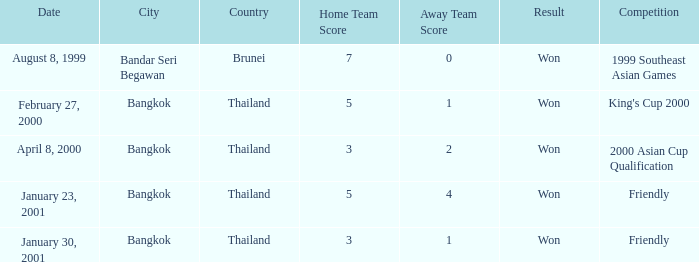What was the date of the game that ended with a 7-0 result? August 8, 1999. 